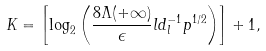<formula> <loc_0><loc_0><loc_500><loc_500>K = \left [ \log _ { 2 } \left ( \frac { 8 \Lambda ( + \infty ) } { \epsilon } l d _ { l } ^ { - 1 } p ^ { 1 / 2 } \right ) \right ] + 1 ,</formula> 